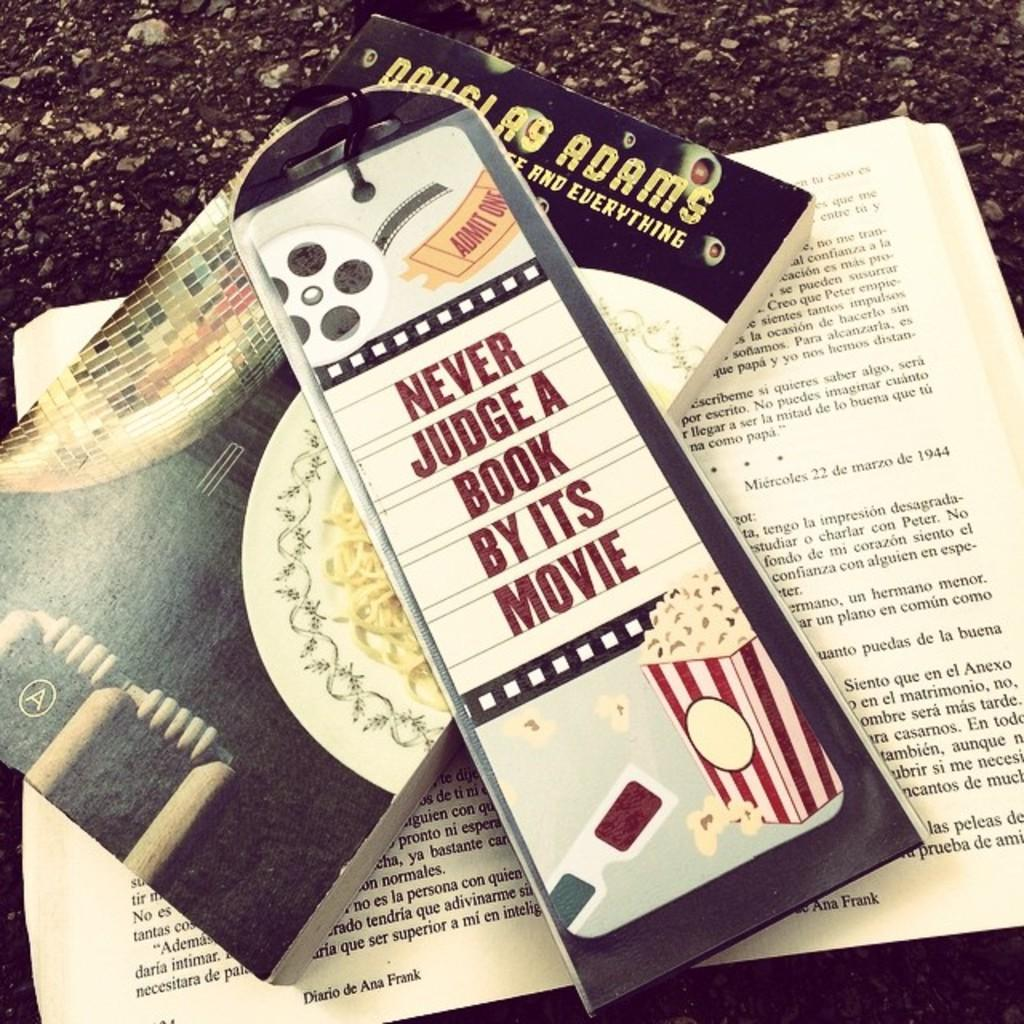<image>
Present a compact description of the photo's key features. A bookmark lying on top of a couple of books warns people to never judge a book by its movie. 